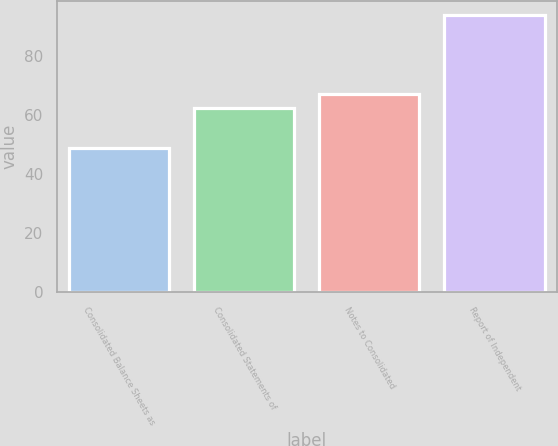Convert chart. <chart><loc_0><loc_0><loc_500><loc_500><bar_chart><fcel>Consolidated Balance Sheets as<fcel>Consolidated Statements of<fcel>Notes to Consolidated<fcel>Report of Independent<nl><fcel>49<fcel>62.5<fcel>67<fcel>94<nl></chart> 